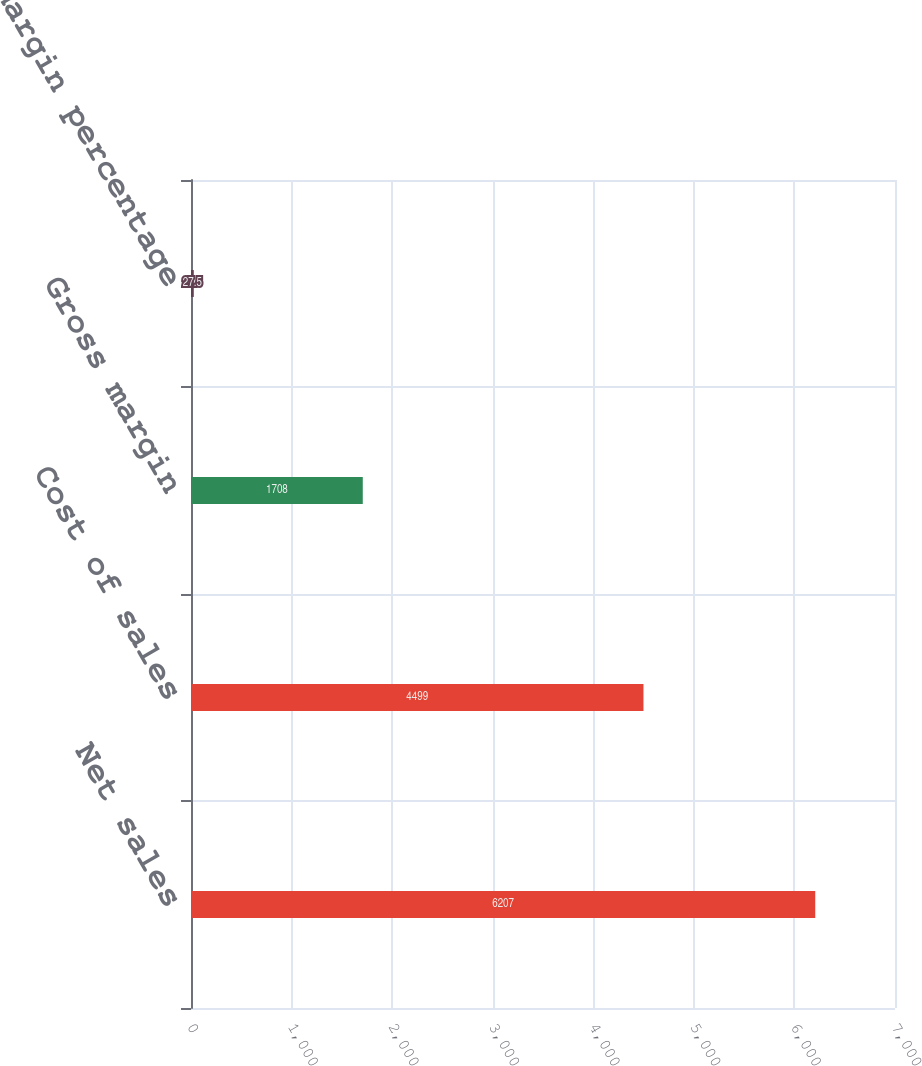<chart> <loc_0><loc_0><loc_500><loc_500><bar_chart><fcel>Net sales<fcel>Cost of sales<fcel>Gross margin<fcel>Gross margin percentage<nl><fcel>6207<fcel>4499<fcel>1708<fcel>27.5<nl></chart> 